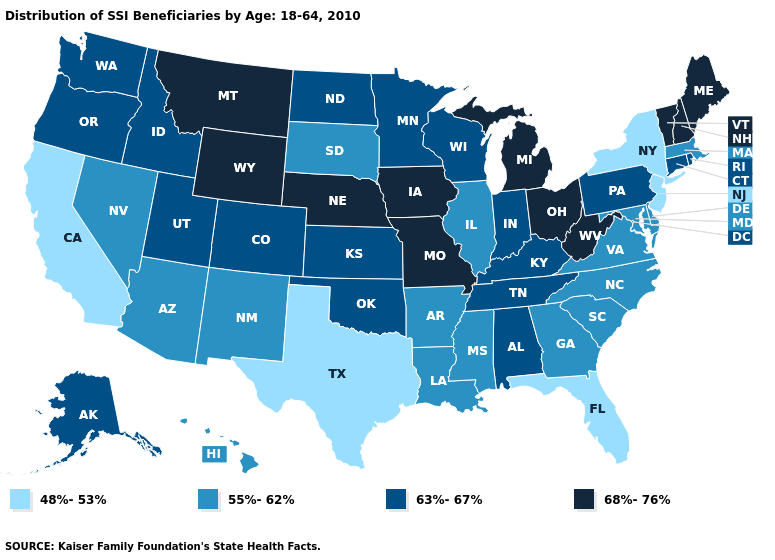Name the states that have a value in the range 63%-67%?
Quick response, please. Alabama, Alaska, Colorado, Connecticut, Idaho, Indiana, Kansas, Kentucky, Minnesota, North Dakota, Oklahoma, Oregon, Pennsylvania, Rhode Island, Tennessee, Utah, Washington, Wisconsin. What is the value of South Dakota?
Write a very short answer. 55%-62%. What is the value of Rhode Island?
Be succinct. 63%-67%. Name the states that have a value in the range 68%-76%?
Short answer required. Iowa, Maine, Michigan, Missouri, Montana, Nebraska, New Hampshire, Ohio, Vermont, West Virginia, Wyoming. What is the lowest value in states that border Oklahoma?
Give a very brief answer. 48%-53%. Does New Hampshire have the same value as Michigan?
Keep it brief. Yes. Does Indiana have the same value as Kentucky?
Give a very brief answer. Yes. Does Nebraska have the same value as Washington?
Quick response, please. No. Name the states that have a value in the range 48%-53%?
Answer briefly. California, Florida, New Jersey, New York, Texas. What is the lowest value in the MidWest?
Short answer required. 55%-62%. Does the map have missing data?
Answer briefly. No. Does Florida have the highest value in the USA?
Write a very short answer. No. Does the first symbol in the legend represent the smallest category?
Give a very brief answer. Yes. Name the states that have a value in the range 48%-53%?
Keep it brief. California, Florida, New Jersey, New York, Texas. Does Illinois have a higher value than New Jersey?
Keep it brief. Yes. 